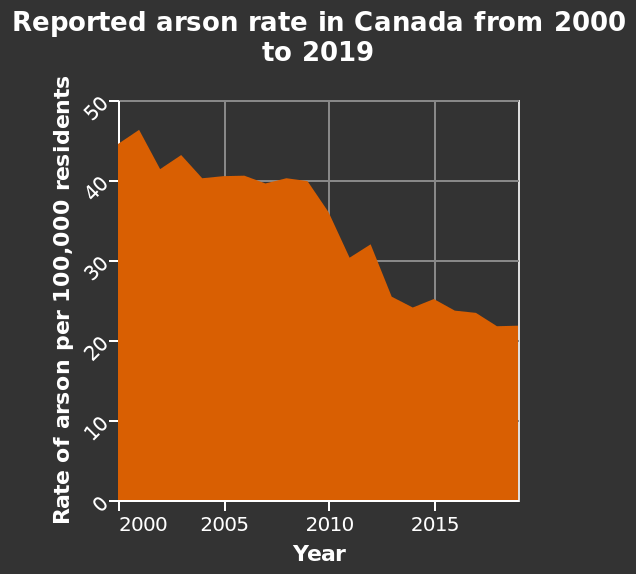<image>
please summary the statistics and relations of the chart The overall trend of the chart suggests that the rate of reported arson in Canada decreased from 2000 to 2019. There was a significant decrease in the rate of reported arson from around 2009 to 2011. The rate in 2000 was approximately 44. The rate in 2019 was approximately 22. 